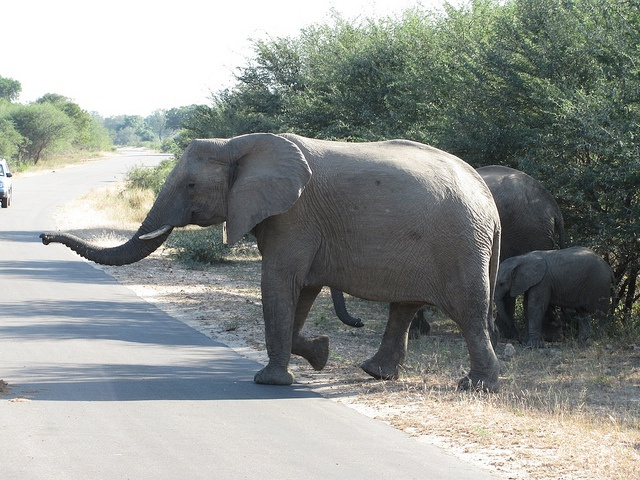Describe the objects in this image and their specific colors. I can see elephant in white, gray, black, lightgray, and darkgray tones, elephant in white, black, gray, and darkblue tones, elephant in white, black, and gray tones, and car in white, darkgray, gray, and black tones in this image. 